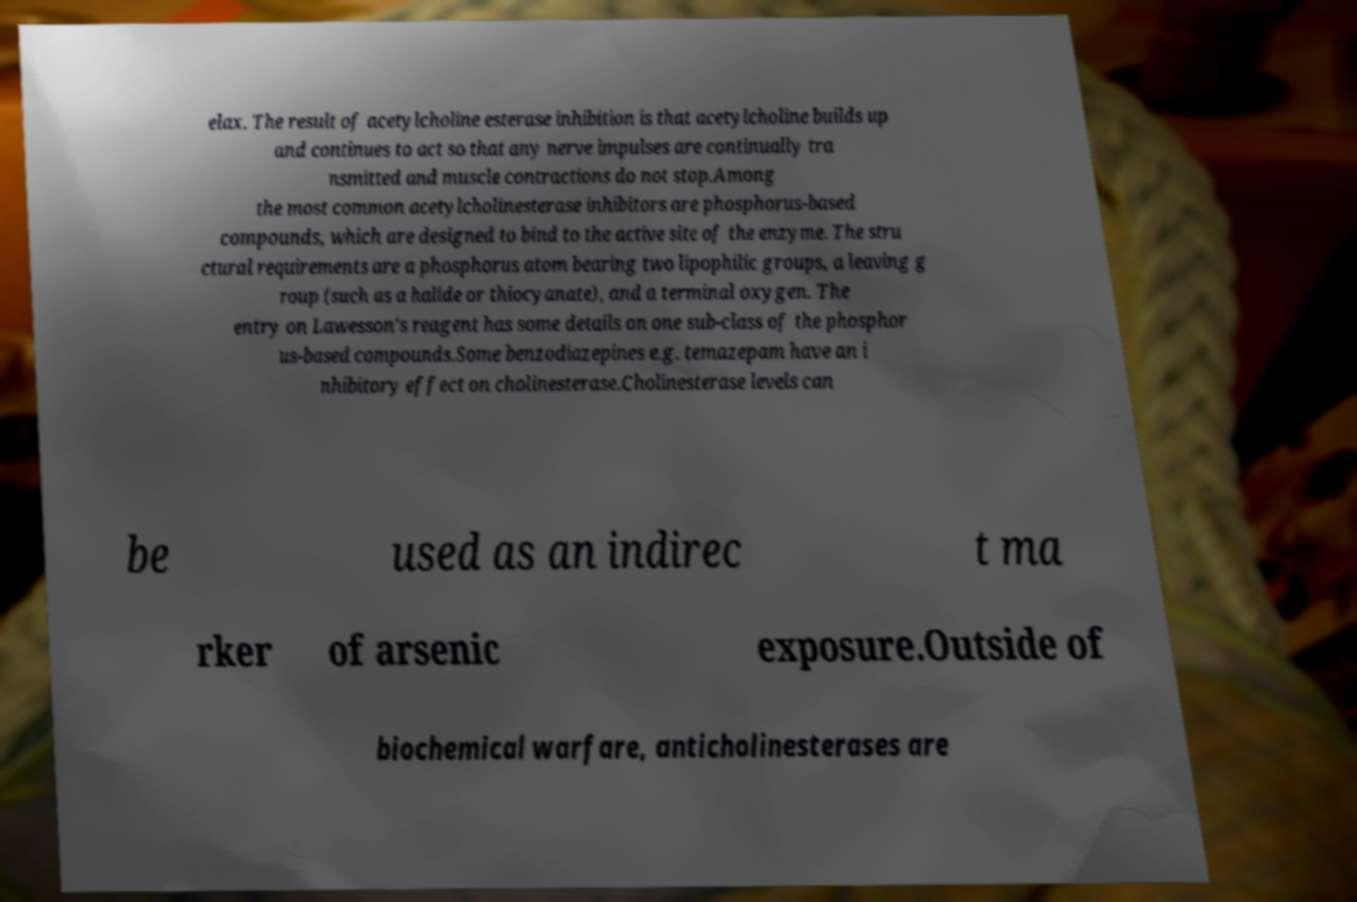Can you accurately transcribe the text from the provided image for me? elax. The result of acetylcholine esterase inhibition is that acetylcholine builds up and continues to act so that any nerve impulses are continually tra nsmitted and muscle contractions do not stop.Among the most common acetylcholinesterase inhibitors are phosphorus-based compounds, which are designed to bind to the active site of the enzyme. The stru ctural requirements are a phosphorus atom bearing two lipophilic groups, a leaving g roup (such as a halide or thiocyanate), and a terminal oxygen. The entry on Lawesson's reagent has some details on one sub-class of the phosphor us-based compounds.Some benzodiazepines e.g. temazepam have an i nhibitory effect on cholinesterase.Cholinesterase levels can be used as an indirec t ma rker of arsenic exposure.Outside of biochemical warfare, anticholinesterases are 